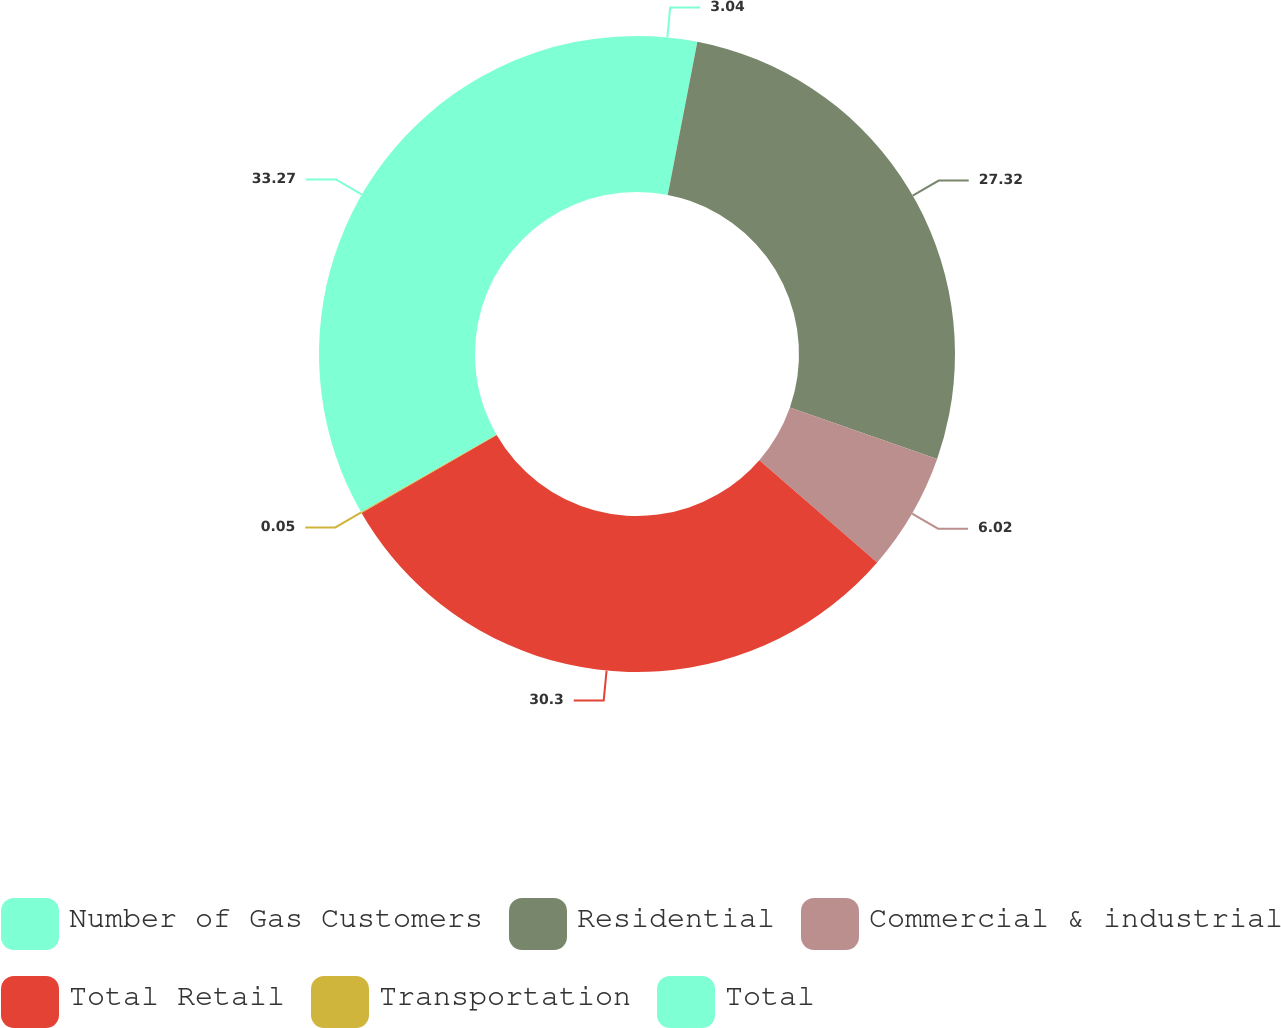<chart> <loc_0><loc_0><loc_500><loc_500><pie_chart><fcel>Number of Gas Customers<fcel>Residential<fcel>Commercial & industrial<fcel>Total Retail<fcel>Transportation<fcel>Total<nl><fcel>3.04%<fcel>27.32%<fcel>6.02%<fcel>30.3%<fcel>0.05%<fcel>33.28%<nl></chart> 